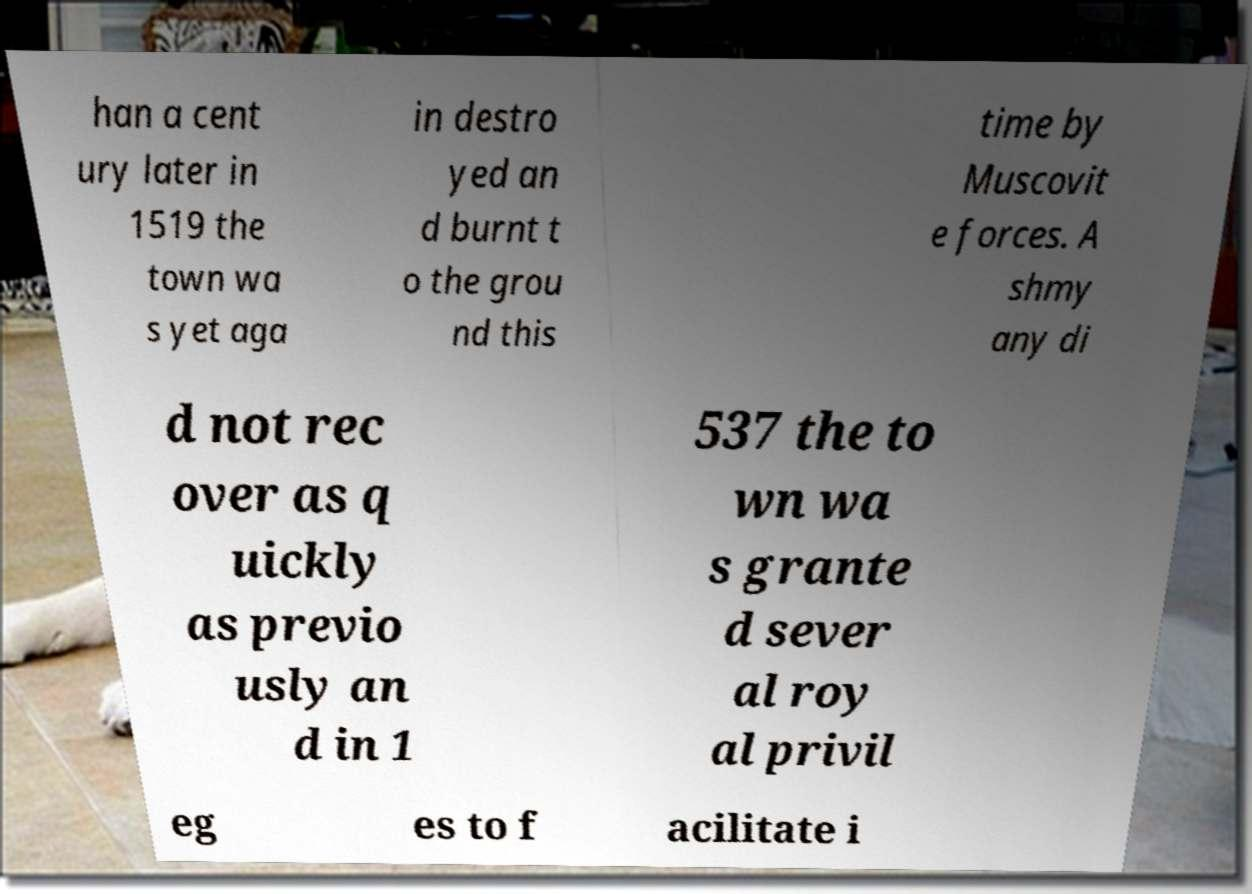Please identify and transcribe the text found in this image. han a cent ury later in 1519 the town wa s yet aga in destro yed an d burnt t o the grou nd this time by Muscovit e forces. A shmy any di d not rec over as q uickly as previo usly an d in 1 537 the to wn wa s grante d sever al roy al privil eg es to f acilitate i 